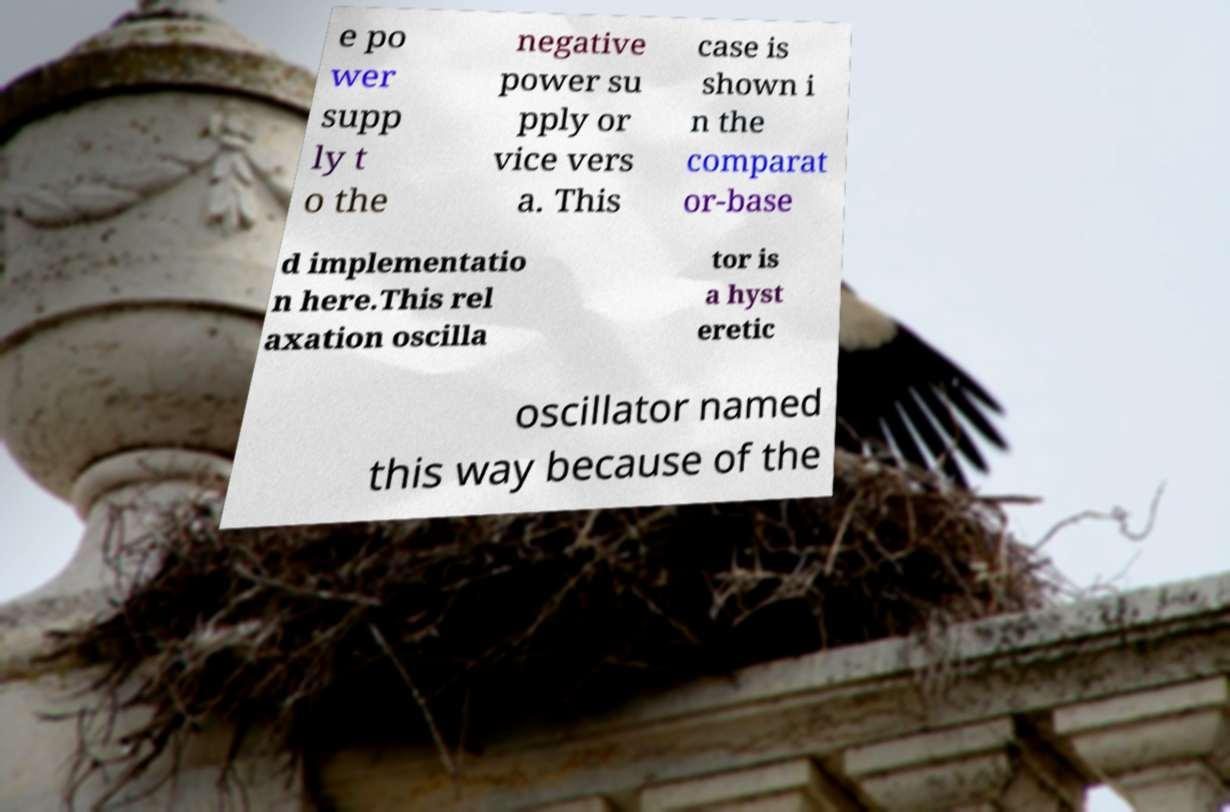Can you read and provide the text displayed in the image?This photo seems to have some interesting text. Can you extract and type it out for me? e po wer supp ly t o the negative power su pply or vice vers a. This case is shown i n the comparat or-base d implementatio n here.This rel axation oscilla tor is a hyst eretic oscillator named this way because of the 